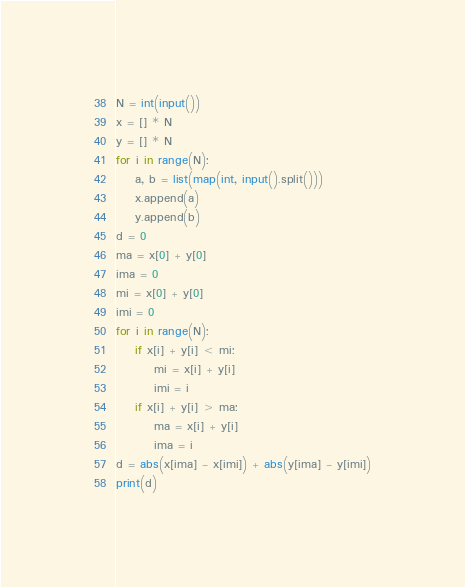Convert code to text. <code><loc_0><loc_0><loc_500><loc_500><_Python_>N = int(input())
x = [] * N
y = [] * N
for i in range(N):
    a, b = list(map(int, input().split()))
    x.append(a)
    y.append(b)
d = 0
ma = x[0] + y[0]
ima = 0
mi = x[0] + y[0]
imi = 0
for i in range(N):
    if x[i] + y[i] < mi:
        mi = x[i] + y[i]
        imi = i
    if x[i] + y[i] > ma:
        ma = x[i] + y[i]
        ima = i
d = abs(x[ima] - x[imi]) + abs(y[ima] - y[imi])
print(d)</code> 